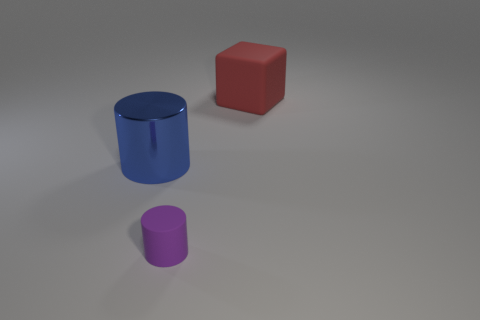Are the big object that is left of the red rubber object and the big thing that is to the right of the rubber cylinder made of the same material?
Your answer should be compact. No. There is a tiny purple thing that is made of the same material as the big red thing; what is its shape?
Your answer should be compact. Cylinder. Is there anything else that is the same color as the large matte cube?
Ensure brevity in your answer.  No. What number of cylinders are there?
Offer a very short reply. 2. What is the material of the object that is to the left of the cylinder right of the metallic cylinder?
Your answer should be very brief. Metal. The matte thing left of the big object behind the large blue metallic cylinder that is left of the tiny purple object is what color?
Keep it short and to the point. Purple. Is the color of the block the same as the big metallic cylinder?
Provide a short and direct response. No. What number of blue objects have the same size as the blue cylinder?
Provide a short and direct response. 0. Are there more big blue metallic things to the right of the small matte cylinder than small purple objects behind the blue metallic object?
Give a very brief answer. No. What is the color of the matte thing that is left of the large object behind the blue metallic cylinder?
Your response must be concise. Purple. 